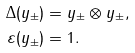Convert formula to latex. <formula><loc_0><loc_0><loc_500><loc_500>\Delta ( y _ { \pm } ) & = y _ { \pm } \otimes y _ { \pm } , \\ \varepsilon ( y _ { \pm } ) & = 1 .</formula> 